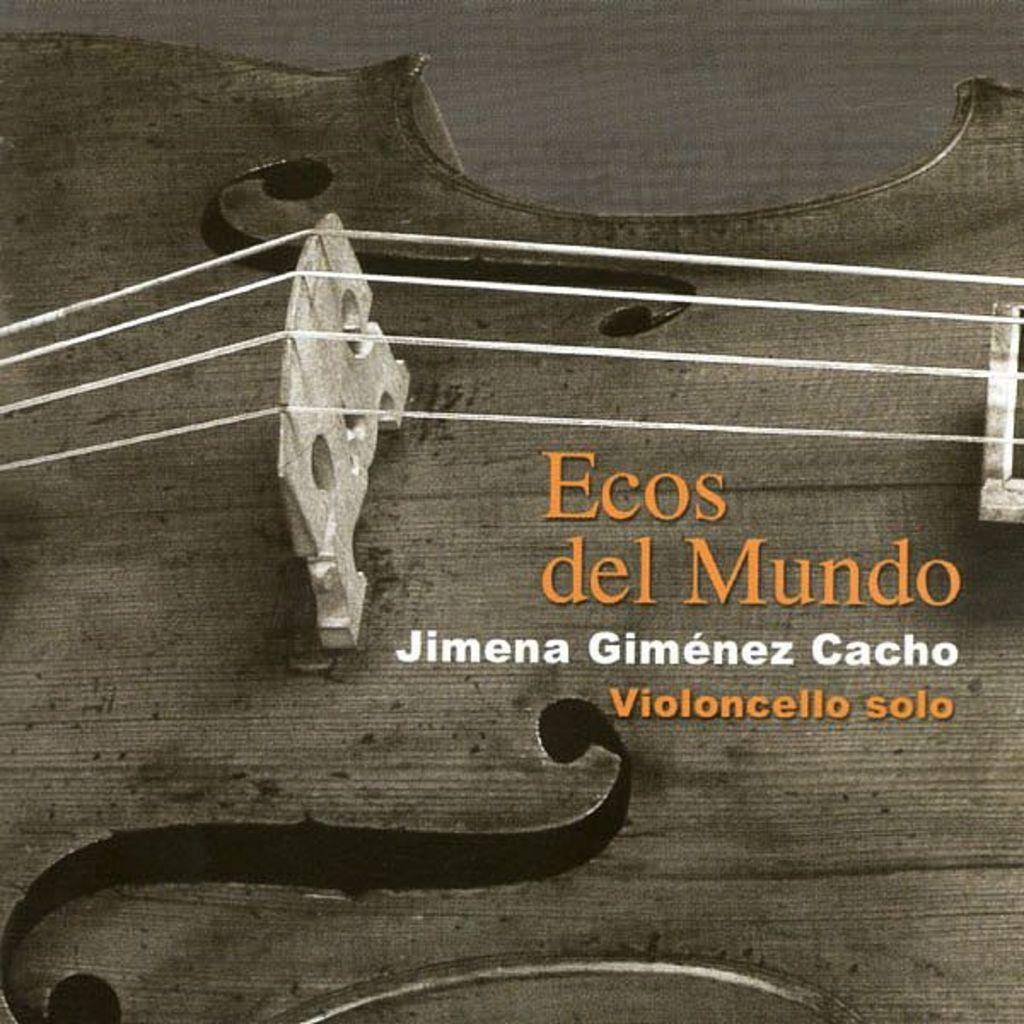What is the main subject of the image? The main subject of the image is a guitar. What specific part of the guitar can be seen in the most clearly in the image? The image contains a close view of a guitar. What feature of the guitar is visible in the image? There are guitar strings visible in the image. What type of apple can be seen falling from the guitar in the image? There is no apple present in the image, and the guitar is not depicted as falling. 